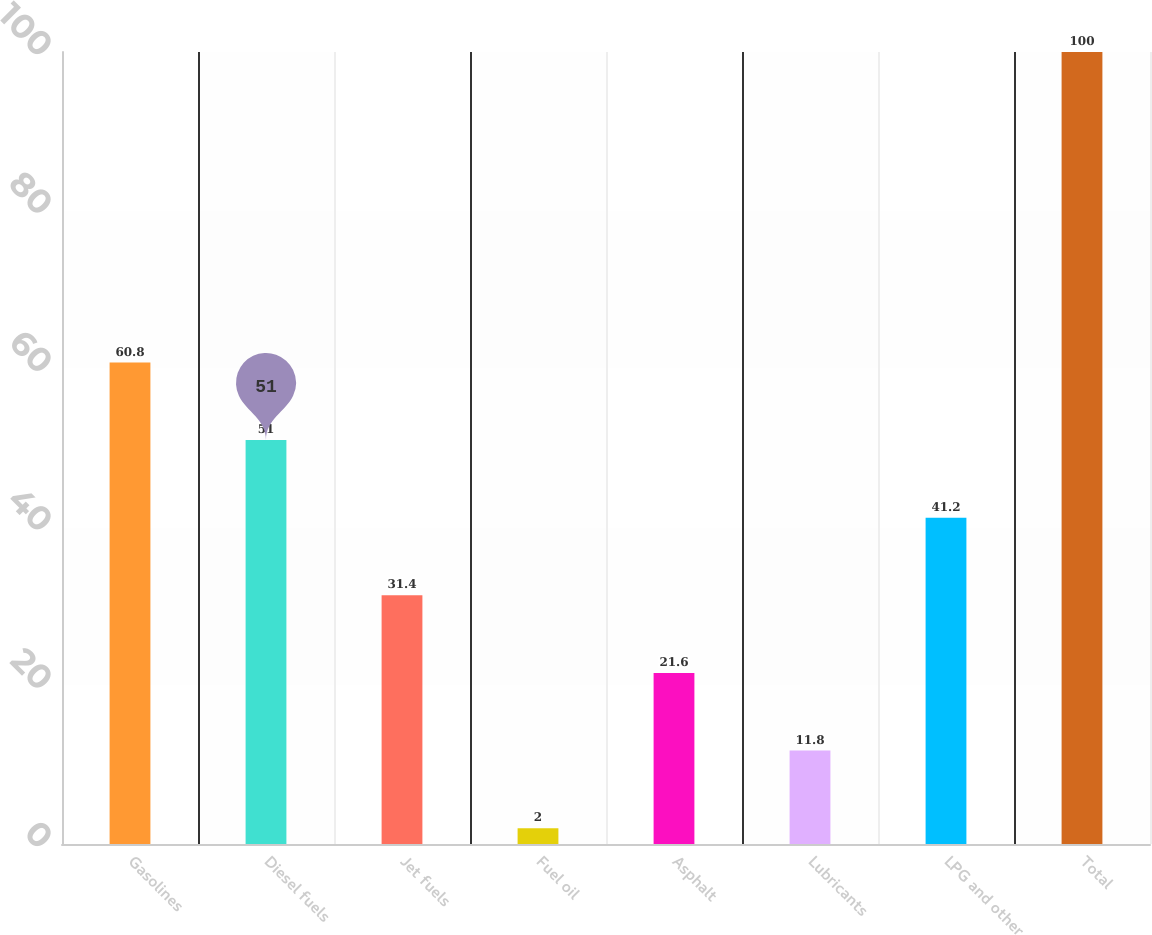Convert chart to OTSL. <chart><loc_0><loc_0><loc_500><loc_500><bar_chart><fcel>Gasolines<fcel>Diesel fuels<fcel>Jet fuels<fcel>Fuel oil<fcel>Asphalt<fcel>Lubricants<fcel>LPG and other<fcel>Total<nl><fcel>60.8<fcel>51<fcel>31.4<fcel>2<fcel>21.6<fcel>11.8<fcel>41.2<fcel>100<nl></chart> 